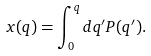Convert formula to latex. <formula><loc_0><loc_0><loc_500><loc_500>x ( q ) = \int _ { 0 } ^ { q } d q ^ { \prime } P ( q ^ { \prime } ) .</formula> 